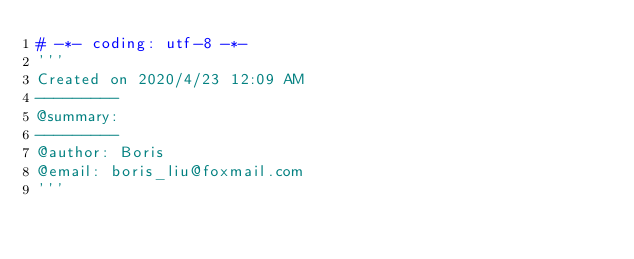<code> <loc_0><loc_0><loc_500><loc_500><_Python_># -*- coding: utf-8 -*-
'''
Created on 2020/4/23 12:09 AM
---------
@summary:
---------
@author: Boris
@email: boris_liu@foxmail.com
'''</code> 